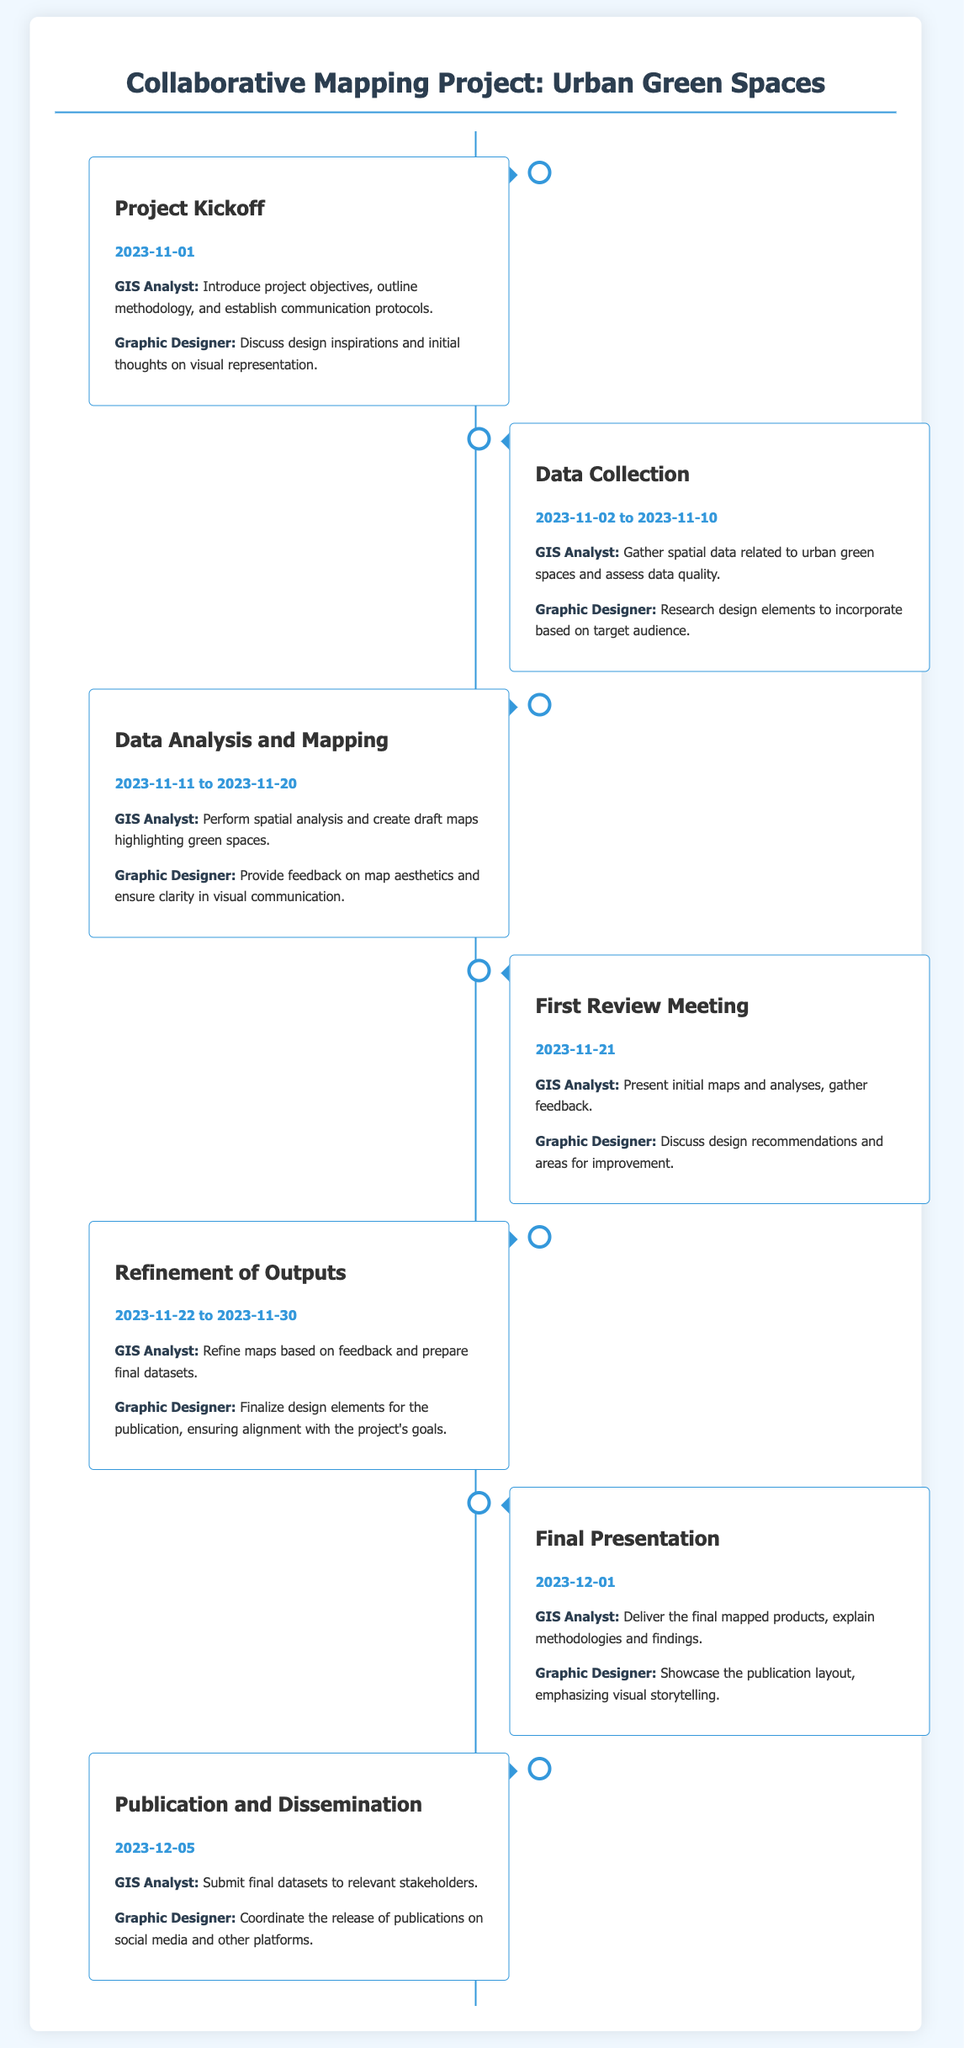What is the title of the project? The title of the project is presented in the main heading of the document.
Answer: Collaborative Mapping Project: Urban Green Spaces When is the Project Kickoff scheduled? The date for the Project Kickoff is clearly mentioned under the milestone description.
Answer: 2023-11-01 What are the dates for Data Collection? The date range for Data Collection is given in the description of that milestone.
Answer: 2023-11-02 to 2023-11-10 Who is responsible for refining maps based on feedback? This responsibility is assigned under the Refinement of Outputs milestone.
Answer: GIS Analyst What is the purpose of the Final Presentation? The purpose is outlined in the final milestone's description.
Answer: Deliver the final mapped products, explain methodologies and findings What two roles are highlighted during the First Review Meeting? The roles mentioned provide clarity on who presents and who gives feedback.
Answer: GIS Analyst and Graphic Designer During which milestone is the design finalized? This information can be found in the content associated with one of the milestones.
Answer: Refinement of Outputs How many days are allocated for Data Analysis and Mapping? The duration can be derived from the dates listed under that milestone.
Answer: 10 days 